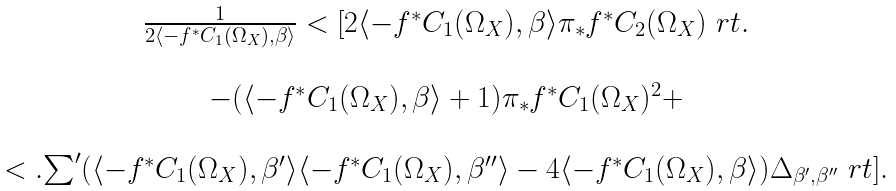<formula> <loc_0><loc_0><loc_500><loc_500>\begin{array} { c } \frac { 1 } { 2 \langle - f ^ { * } C _ { 1 } ( \Omega _ { X } ) , \beta \rangle } < [ 2 \langle - f ^ { * } C _ { 1 } ( \Omega _ { X } ) , \beta \rangle \pi _ { * } f ^ { * } C _ { 2 } ( \Omega _ { X } ) \ r t . \\ \\ - ( \langle - f ^ { * } C _ { 1 } ( \Omega _ { X } ) , \beta \rangle + 1 ) \pi _ { * } f ^ { * } C _ { 1 } ( \Omega _ { X } ) ^ { 2 } + \\ \\ < . { \sum } ^ { \prime } ( \langle - f ^ { * } C _ { 1 } ( \Omega _ { X } ) , \beta ^ { \prime } \rangle \langle - f ^ { * } C _ { 1 } ( \Omega _ { X } ) , \beta ^ { \prime \prime } \rangle - 4 \langle - f ^ { * } C _ { 1 } ( \Omega _ { X } ) , \beta \rangle ) \Delta _ { \beta ^ { \prime } , \beta ^ { \prime \prime } } \ r t ] . \end{array}</formula> 